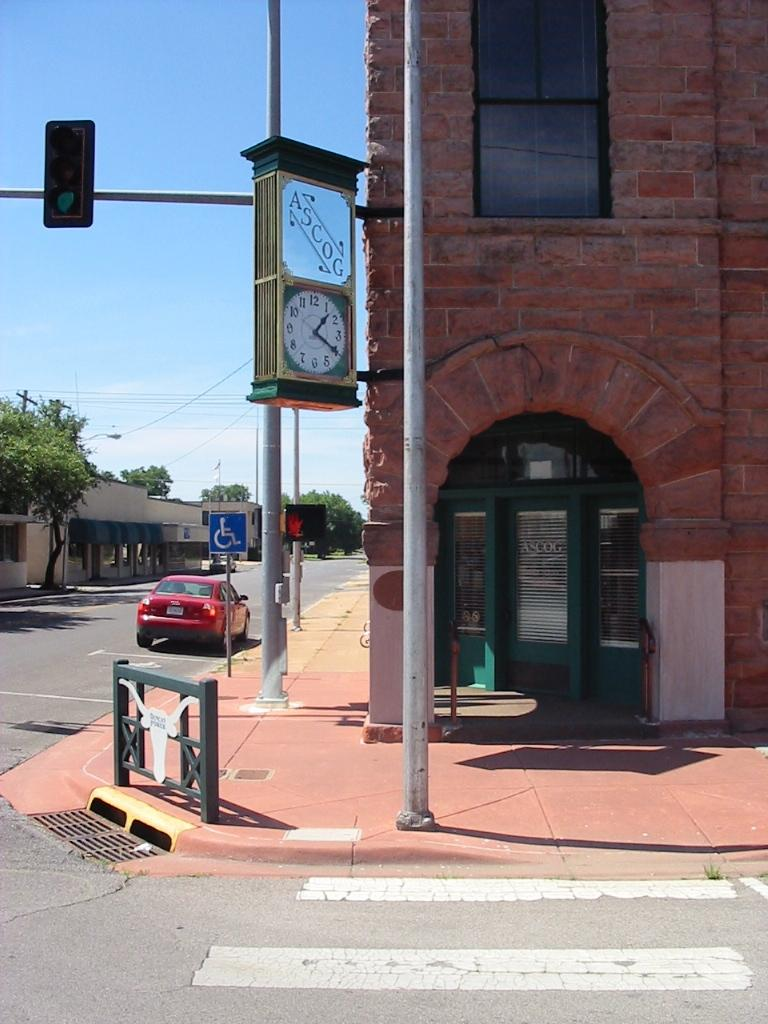<image>
Write a terse but informative summary of the picture. A clock with ASCOG above it is hanging on a pole at a corner of a street. 